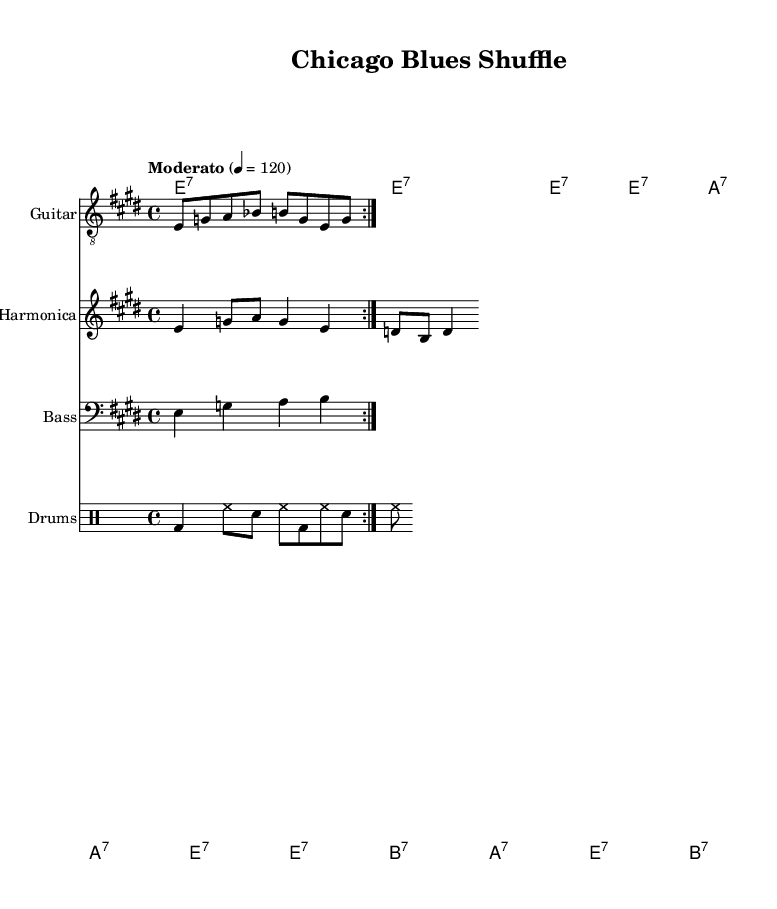What is the key signature of this music? The key signature is E major, which has four sharps (F#, C#, G#, D#). This can be identified by looking at the key signature section at the beginning of the score.
Answer: E major What is the time signature of this music? The time signature is 4/4, which indicates that there are four beats in each measure and the quarter note gets one beat. This can be found at the start of the score.
Answer: 4/4 What is the tempo marking for this piece? The tempo marking is "Moderato," which gives a performance directive for the music to be played at a moderate pace, generally around 108-120 beats per minute. The actual number indicating speed is shown next to the tempo marking.
Answer: Moderato How many measures are repeated for the guitar riff? The guitar riff is indicated to repeat twice within the score, as shown by the "repeat volta" notation that specifies how many times the section is to be played.
Answer: 2 Which instruments are featured in this arrangement? The arrangement includes a guitar, harmonica, bass, and drums. This can be confirmed by looking at the instrument names listed for each staff in the score.
Answer: Guitar, Harmonica, Bass, Drums What type of chords are used in the chord progression? The chord progression consists of dominant seventh chords (e.g., E7, A7, B7), which are typical in blues music for creating a sense of tension and resolution. The specific chords are noted in the chord names section of the score.
Answer: Dominant seventh What is the primary focus instrument in Classic Chicago-style electric blues? The primary focus instrument in this style is the electric guitar, as it often delivers the signature riffs and solos characteristic of the genre. This emphasis can be inferred from the arrangement, where the guitar has a dedicated staff and opportunity for embellishment.
Answer: Electric guitar 